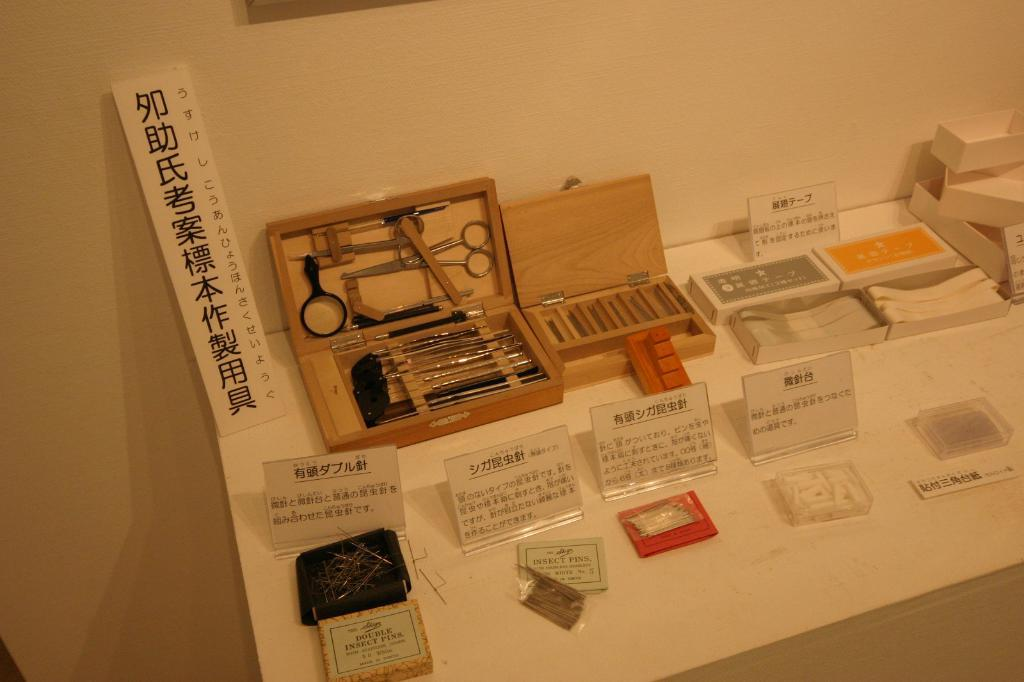Provide a one-sentence caption for the provided image. many different items that have Japanese writing on them. 